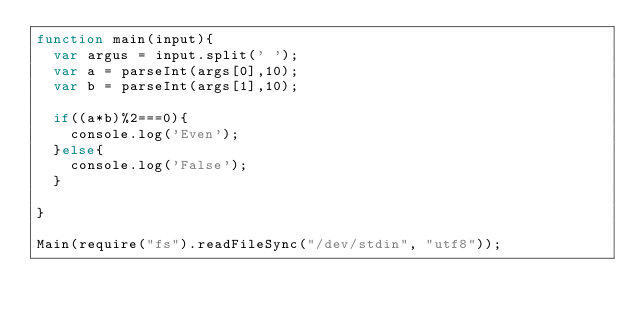Convert code to text. <code><loc_0><loc_0><loc_500><loc_500><_JavaScript_>function main(input){
	var argus = input.split(' ');
	var a = parseInt(args[0],10);
	var b = parseInt(args[1],10);
	
	if((a*b)%2===0){
		console.log('Even');
	}else{
		console.log('False');
	}
		
}

Main(require("fs").readFileSync("/dev/stdin", "utf8"));</code> 